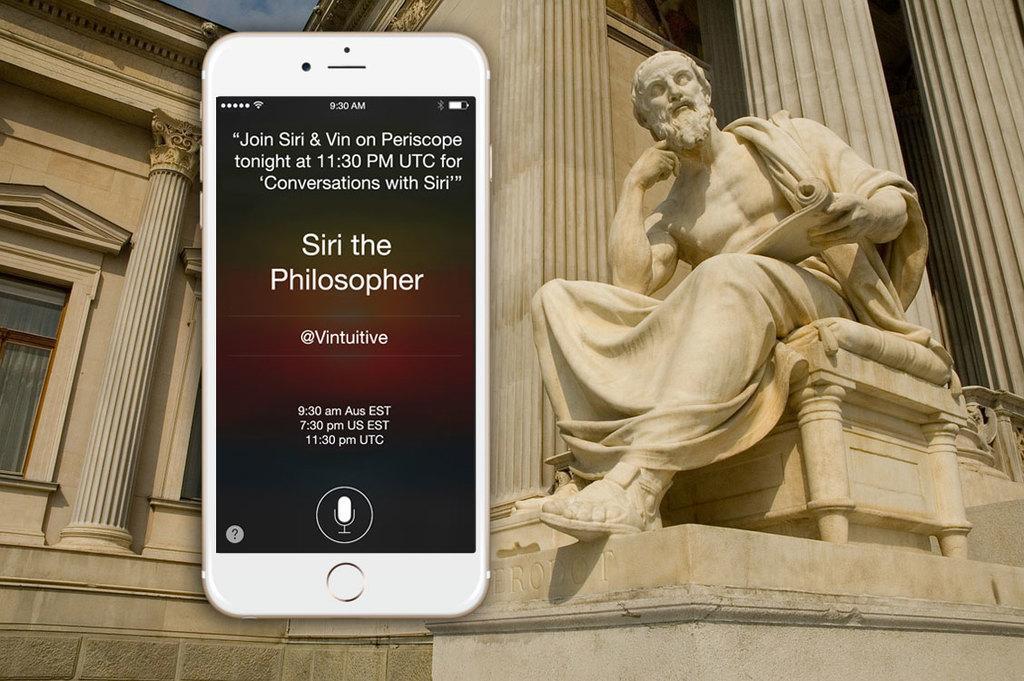Describe this image in one or two sentences. In this image I can see a white colour sculpture of a man and white colour building. Here I can see depiction of a phone and I can see something is written over here. 